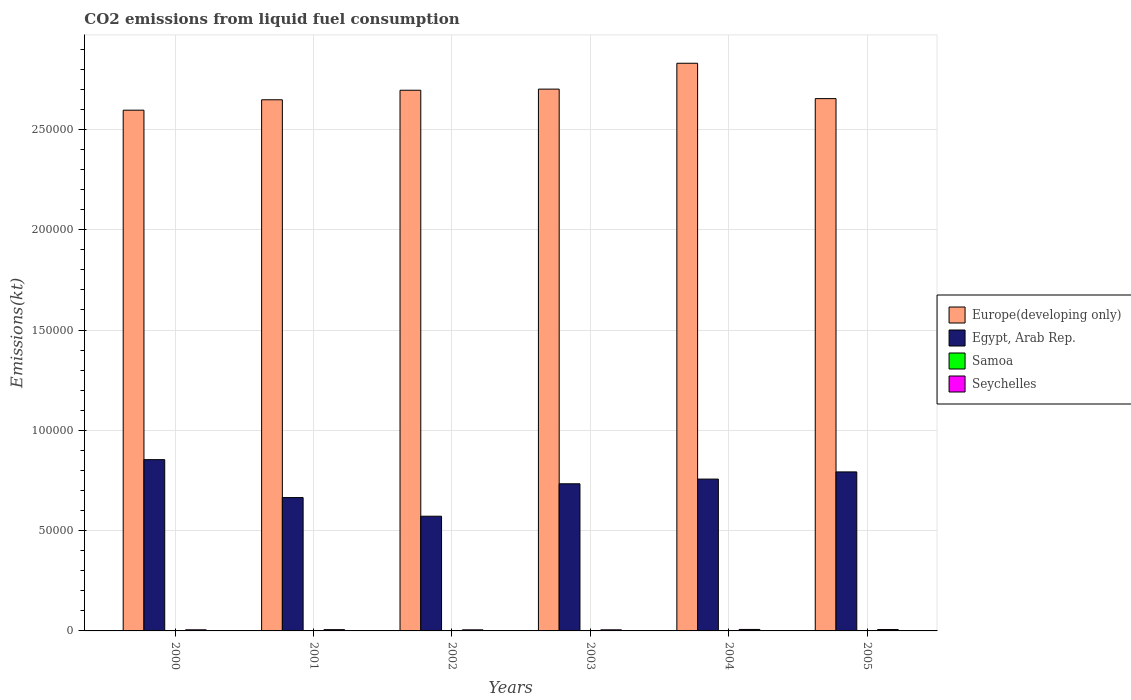What is the amount of CO2 emitted in Samoa in 2000?
Offer a terse response. 139.35. Across all years, what is the maximum amount of CO2 emitted in Europe(developing only)?
Offer a terse response. 2.83e+05. Across all years, what is the minimum amount of CO2 emitted in Egypt, Arab Rep.?
Make the answer very short. 5.72e+04. What is the total amount of CO2 emitted in Samoa in the graph?
Provide a short and direct response. 905.75. What is the difference between the amount of CO2 emitted in Samoa in 2001 and that in 2004?
Give a very brief answer. -18.34. What is the difference between the amount of CO2 emitted in Seychelles in 2000 and the amount of CO2 emitted in Samoa in 2004?
Your answer should be compact. 396.04. What is the average amount of CO2 emitted in Egypt, Arab Rep. per year?
Provide a succinct answer. 7.29e+04. In the year 2004, what is the difference between the amount of CO2 emitted in Egypt, Arab Rep. and amount of CO2 emitted in Samoa?
Make the answer very short. 7.55e+04. What is the ratio of the amount of CO2 emitted in Seychelles in 2003 to that in 2005?
Make the answer very short. 0.8. Is the amount of CO2 emitted in Europe(developing only) in 2001 less than that in 2004?
Make the answer very short. Yes. Is the difference between the amount of CO2 emitted in Egypt, Arab Rep. in 2001 and 2002 greater than the difference between the amount of CO2 emitted in Samoa in 2001 and 2002?
Your answer should be very brief. Yes. What is the difference between the highest and the second highest amount of CO2 emitted in Samoa?
Ensure brevity in your answer.  7.33. What is the difference between the highest and the lowest amount of CO2 emitted in Europe(developing only)?
Give a very brief answer. 2.34e+04. Is the sum of the amount of CO2 emitted in Seychelles in 2000 and 2005 greater than the maximum amount of CO2 emitted in Egypt, Arab Rep. across all years?
Make the answer very short. No. Is it the case that in every year, the sum of the amount of CO2 emitted in Egypt, Arab Rep. and amount of CO2 emitted in Europe(developing only) is greater than the sum of amount of CO2 emitted in Seychelles and amount of CO2 emitted in Samoa?
Your answer should be very brief. Yes. What does the 1st bar from the left in 2003 represents?
Offer a very short reply. Europe(developing only). What does the 1st bar from the right in 2004 represents?
Give a very brief answer. Seychelles. Is it the case that in every year, the sum of the amount of CO2 emitted in Europe(developing only) and amount of CO2 emitted in Egypt, Arab Rep. is greater than the amount of CO2 emitted in Samoa?
Offer a very short reply. Yes. How many bars are there?
Provide a short and direct response. 24. Are all the bars in the graph horizontal?
Ensure brevity in your answer.  No. What is the difference between two consecutive major ticks on the Y-axis?
Make the answer very short. 5.00e+04. Are the values on the major ticks of Y-axis written in scientific E-notation?
Keep it short and to the point. No. How many legend labels are there?
Ensure brevity in your answer.  4. What is the title of the graph?
Offer a terse response. CO2 emissions from liquid fuel consumption. What is the label or title of the X-axis?
Provide a succinct answer. Years. What is the label or title of the Y-axis?
Provide a succinct answer. Emissions(kt). What is the Emissions(kt) of Europe(developing only) in 2000?
Provide a short and direct response. 2.60e+05. What is the Emissions(kt) of Egypt, Arab Rep. in 2000?
Provide a short and direct response. 8.54e+04. What is the Emissions(kt) of Samoa in 2000?
Your answer should be very brief. 139.35. What is the Emissions(kt) in Seychelles in 2000?
Make the answer very short. 557.38. What is the Emissions(kt) of Europe(developing only) in 2001?
Your answer should be compact. 2.65e+05. What is the Emissions(kt) in Egypt, Arab Rep. in 2001?
Your answer should be very brief. 6.65e+04. What is the Emissions(kt) of Samoa in 2001?
Provide a short and direct response. 143.01. What is the Emissions(kt) in Seychelles in 2001?
Your response must be concise. 634.39. What is the Emissions(kt) in Europe(developing only) in 2002?
Make the answer very short. 2.70e+05. What is the Emissions(kt) in Egypt, Arab Rep. in 2002?
Make the answer very short. 5.72e+04. What is the Emissions(kt) in Samoa in 2002?
Ensure brevity in your answer.  143.01. What is the Emissions(kt) of Seychelles in 2002?
Offer a very short reply. 539.05. What is the Emissions(kt) of Europe(developing only) in 2003?
Offer a terse response. 2.70e+05. What is the Emissions(kt) in Egypt, Arab Rep. in 2003?
Keep it short and to the point. 7.34e+04. What is the Emissions(kt) in Samoa in 2003?
Keep it short and to the point. 150.35. What is the Emissions(kt) of Seychelles in 2003?
Your answer should be very brief. 550.05. What is the Emissions(kt) in Europe(developing only) in 2004?
Offer a very short reply. 2.83e+05. What is the Emissions(kt) of Egypt, Arab Rep. in 2004?
Your response must be concise. 7.57e+04. What is the Emissions(kt) of Samoa in 2004?
Offer a terse response. 161.35. What is the Emissions(kt) in Seychelles in 2004?
Your answer should be compact. 737.07. What is the Emissions(kt) of Europe(developing only) in 2005?
Make the answer very short. 2.65e+05. What is the Emissions(kt) in Egypt, Arab Rep. in 2005?
Your answer should be compact. 7.93e+04. What is the Emissions(kt) of Samoa in 2005?
Offer a very short reply. 168.68. What is the Emissions(kt) of Seychelles in 2005?
Give a very brief answer. 689.4. Across all years, what is the maximum Emissions(kt) in Europe(developing only)?
Your answer should be very brief. 2.83e+05. Across all years, what is the maximum Emissions(kt) in Egypt, Arab Rep.?
Give a very brief answer. 8.54e+04. Across all years, what is the maximum Emissions(kt) of Samoa?
Keep it short and to the point. 168.68. Across all years, what is the maximum Emissions(kt) of Seychelles?
Your answer should be compact. 737.07. Across all years, what is the minimum Emissions(kt) of Europe(developing only)?
Keep it short and to the point. 2.60e+05. Across all years, what is the minimum Emissions(kt) of Egypt, Arab Rep.?
Ensure brevity in your answer.  5.72e+04. Across all years, what is the minimum Emissions(kt) in Samoa?
Offer a very short reply. 139.35. Across all years, what is the minimum Emissions(kt) in Seychelles?
Offer a terse response. 539.05. What is the total Emissions(kt) of Europe(developing only) in the graph?
Provide a succinct answer. 1.61e+06. What is the total Emissions(kt) in Egypt, Arab Rep. in the graph?
Your response must be concise. 4.37e+05. What is the total Emissions(kt) of Samoa in the graph?
Provide a succinct answer. 905.75. What is the total Emissions(kt) of Seychelles in the graph?
Keep it short and to the point. 3707.34. What is the difference between the Emissions(kt) of Europe(developing only) in 2000 and that in 2001?
Your response must be concise. -5184.91. What is the difference between the Emissions(kt) of Egypt, Arab Rep. in 2000 and that in 2001?
Your answer should be very brief. 1.89e+04. What is the difference between the Emissions(kt) of Samoa in 2000 and that in 2001?
Keep it short and to the point. -3.67. What is the difference between the Emissions(kt) of Seychelles in 2000 and that in 2001?
Provide a succinct answer. -77.01. What is the difference between the Emissions(kt) in Europe(developing only) in 2000 and that in 2002?
Provide a succinct answer. -9939.01. What is the difference between the Emissions(kt) in Egypt, Arab Rep. in 2000 and that in 2002?
Offer a terse response. 2.82e+04. What is the difference between the Emissions(kt) in Samoa in 2000 and that in 2002?
Provide a short and direct response. -3.67. What is the difference between the Emissions(kt) of Seychelles in 2000 and that in 2002?
Your answer should be very brief. 18.34. What is the difference between the Emissions(kt) of Europe(developing only) in 2000 and that in 2003?
Give a very brief answer. -1.05e+04. What is the difference between the Emissions(kt) in Egypt, Arab Rep. in 2000 and that in 2003?
Offer a very short reply. 1.20e+04. What is the difference between the Emissions(kt) in Samoa in 2000 and that in 2003?
Provide a succinct answer. -11. What is the difference between the Emissions(kt) in Seychelles in 2000 and that in 2003?
Offer a terse response. 7.33. What is the difference between the Emissions(kt) of Europe(developing only) in 2000 and that in 2004?
Make the answer very short. -2.34e+04. What is the difference between the Emissions(kt) in Egypt, Arab Rep. in 2000 and that in 2004?
Make the answer very short. 9691.88. What is the difference between the Emissions(kt) in Samoa in 2000 and that in 2004?
Offer a terse response. -22. What is the difference between the Emissions(kt) in Seychelles in 2000 and that in 2004?
Your response must be concise. -179.68. What is the difference between the Emissions(kt) in Europe(developing only) in 2000 and that in 2005?
Make the answer very short. -5768.21. What is the difference between the Emissions(kt) of Egypt, Arab Rep. in 2000 and that in 2005?
Give a very brief answer. 6112.89. What is the difference between the Emissions(kt) of Samoa in 2000 and that in 2005?
Provide a short and direct response. -29.34. What is the difference between the Emissions(kt) in Seychelles in 2000 and that in 2005?
Make the answer very short. -132.01. What is the difference between the Emissions(kt) of Europe(developing only) in 2001 and that in 2002?
Ensure brevity in your answer.  -4754.1. What is the difference between the Emissions(kt) of Egypt, Arab Rep. in 2001 and that in 2002?
Your response must be concise. 9306.85. What is the difference between the Emissions(kt) in Seychelles in 2001 and that in 2002?
Make the answer very short. 95.34. What is the difference between the Emissions(kt) in Europe(developing only) in 2001 and that in 2003?
Offer a terse response. -5318.34. What is the difference between the Emissions(kt) in Egypt, Arab Rep. in 2001 and that in 2003?
Make the answer very short. -6868.29. What is the difference between the Emissions(kt) in Samoa in 2001 and that in 2003?
Provide a succinct answer. -7.33. What is the difference between the Emissions(kt) of Seychelles in 2001 and that in 2003?
Keep it short and to the point. 84.34. What is the difference between the Emissions(kt) of Europe(developing only) in 2001 and that in 2004?
Offer a terse response. -1.82e+04. What is the difference between the Emissions(kt) of Egypt, Arab Rep. in 2001 and that in 2004?
Your response must be concise. -9211.5. What is the difference between the Emissions(kt) of Samoa in 2001 and that in 2004?
Provide a succinct answer. -18.34. What is the difference between the Emissions(kt) in Seychelles in 2001 and that in 2004?
Provide a succinct answer. -102.68. What is the difference between the Emissions(kt) in Europe(developing only) in 2001 and that in 2005?
Ensure brevity in your answer.  -583.3. What is the difference between the Emissions(kt) of Egypt, Arab Rep. in 2001 and that in 2005?
Offer a very short reply. -1.28e+04. What is the difference between the Emissions(kt) in Samoa in 2001 and that in 2005?
Offer a very short reply. -25.67. What is the difference between the Emissions(kt) in Seychelles in 2001 and that in 2005?
Keep it short and to the point. -55.01. What is the difference between the Emissions(kt) in Europe(developing only) in 2002 and that in 2003?
Keep it short and to the point. -564.24. What is the difference between the Emissions(kt) of Egypt, Arab Rep. in 2002 and that in 2003?
Your answer should be very brief. -1.62e+04. What is the difference between the Emissions(kt) in Samoa in 2002 and that in 2003?
Give a very brief answer. -7.33. What is the difference between the Emissions(kt) in Seychelles in 2002 and that in 2003?
Make the answer very short. -11. What is the difference between the Emissions(kt) in Europe(developing only) in 2002 and that in 2004?
Your response must be concise. -1.35e+04. What is the difference between the Emissions(kt) in Egypt, Arab Rep. in 2002 and that in 2004?
Offer a very short reply. -1.85e+04. What is the difference between the Emissions(kt) in Samoa in 2002 and that in 2004?
Give a very brief answer. -18.34. What is the difference between the Emissions(kt) in Seychelles in 2002 and that in 2004?
Your response must be concise. -198.02. What is the difference between the Emissions(kt) of Europe(developing only) in 2002 and that in 2005?
Provide a short and direct response. 4170.8. What is the difference between the Emissions(kt) in Egypt, Arab Rep. in 2002 and that in 2005?
Your answer should be very brief. -2.21e+04. What is the difference between the Emissions(kt) in Samoa in 2002 and that in 2005?
Ensure brevity in your answer.  -25.67. What is the difference between the Emissions(kt) in Seychelles in 2002 and that in 2005?
Ensure brevity in your answer.  -150.35. What is the difference between the Emissions(kt) in Europe(developing only) in 2003 and that in 2004?
Offer a terse response. -1.29e+04. What is the difference between the Emissions(kt) in Egypt, Arab Rep. in 2003 and that in 2004?
Give a very brief answer. -2343.21. What is the difference between the Emissions(kt) in Samoa in 2003 and that in 2004?
Keep it short and to the point. -11. What is the difference between the Emissions(kt) of Seychelles in 2003 and that in 2004?
Offer a very short reply. -187.02. What is the difference between the Emissions(kt) in Europe(developing only) in 2003 and that in 2005?
Ensure brevity in your answer.  4735.04. What is the difference between the Emissions(kt) of Egypt, Arab Rep. in 2003 and that in 2005?
Keep it short and to the point. -5922.2. What is the difference between the Emissions(kt) in Samoa in 2003 and that in 2005?
Your answer should be compact. -18.34. What is the difference between the Emissions(kt) in Seychelles in 2003 and that in 2005?
Give a very brief answer. -139.35. What is the difference between the Emissions(kt) in Europe(developing only) in 2004 and that in 2005?
Provide a short and direct response. 1.76e+04. What is the difference between the Emissions(kt) of Egypt, Arab Rep. in 2004 and that in 2005?
Your answer should be very brief. -3578.99. What is the difference between the Emissions(kt) in Samoa in 2004 and that in 2005?
Keep it short and to the point. -7.33. What is the difference between the Emissions(kt) in Seychelles in 2004 and that in 2005?
Your response must be concise. 47.67. What is the difference between the Emissions(kt) of Europe(developing only) in 2000 and the Emissions(kt) of Egypt, Arab Rep. in 2001?
Give a very brief answer. 1.93e+05. What is the difference between the Emissions(kt) of Europe(developing only) in 2000 and the Emissions(kt) of Samoa in 2001?
Offer a terse response. 2.59e+05. What is the difference between the Emissions(kt) of Europe(developing only) in 2000 and the Emissions(kt) of Seychelles in 2001?
Ensure brevity in your answer.  2.59e+05. What is the difference between the Emissions(kt) of Egypt, Arab Rep. in 2000 and the Emissions(kt) of Samoa in 2001?
Your answer should be compact. 8.52e+04. What is the difference between the Emissions(kt) in Egypt, Arab Rep. in 2000 and the Emissions(kt) in Seychelles in 2001?
Provide a short and direct response. 8.48e+04. What is the difference between the Emissions(kt) in Samoa in 2000 and the Emissions(kt) in Seychelles in 2001?
Your answer should be compact. -495.05. What is the difference between the Emissions(kt) in Europe(developing only) in 2000 and the Emissions(kt) in Egypt, Arab Rep. in 2002?
Keep it short and to the point. 2.02e+05. What is the difference between the Emissions(kt) of Europe(developing only) in 2000 and the Emissions(kt) of Samoa in 2002?
Your answer should be very brief. 2.59e+05. What is the difference between the Emissions(kt) of Europe(developing only) in 2000 and the Emissions(kt) of Seychelles in 2002?
Offer a terse response. 2.59e+05. What is the difference between the Emissions(kt) of Egypt, Arab Rep. in 2000 and the Emissions(kt) of Samoa in 2002?
Your response must be concise. 8.52e+04. What is the difference between the Emissions(kt) in Egypt, Arab Rep. in 2000 and the Emissions(kt) in Seychelles in 2002?
Ensure brevity in your answer.  8.49e+04. What is the difference between the Emissions(kt) in Samoa in 2000 and the Emissions(kt) in Seychelles in 2002?
Ensure brevity in your answer.  -399.7. What is the difference between the Emissions(kt) of Europe(developing only) in 2000 and the Emissions(kt) of Egypt, Arab Rep. in 2003?
Provide a short and direct response. 1.86e+05. What is the difference between the Emissions(kt) of Europe(developing only) in 2000 and the Emissions(kt) of Samoa in 2003?
Give a very brief answer. 2.59e+05. What is the difference between the Emissions(kt) of Europe(developing only) in 2000 and the Emissions(kt) of Seychelles in 2003?
Offer a very short reply. 2.59e+05. What is the difference between the Emissions(kt) of Egypt, Arab Rep. in 2000 and the Emissions(kt) of Samoa in 2003?
Your answer should be compact. 8.52e+04. What is the difference between the Emissions(kt) of Egypt, Arab Rep. in 2000 and the Emissions(kt) of Seychelles in 2003?
Your response must be concise. 8.48e+04. What is the difference between the Emissions(kt) in Samoa in 2000 and the Emissions(kt) in Seychelles in 2003?
Provide a succinct answer. -410.7. What is the difference between the Emissions(kt) of Europe(developing only) in 2000 and the Emissions(kt) of Egypt, Arab Rep. in 2004?
Your answer should be very brief. 1.84e+05. What is the difference between the Emissions(kt) in Europe(developing only) in 2000 and the Emissions(kt) in Samoa in 2004?
Keep it short and to the point. 2.59e+05. What is the difference between the Emissions(kt) of Europe(developing only) in 2000 and the Emissions(kt) of Seychelles in 2004?
Make the answer very short. 2.59e+05. What is the difference between the Emissions(kt) of Egypt, Arab Rep. in 2000 and the Emissions(kt) of Samoa in 2004?
Ensure brevity in your answer.  8.52e+04. What is the difference between the Emissions(kt) in Egypt, Arab Rep. in 2000 and the Emissions(kt) in Seychelles in 2004?
Your answer should be compact. 8.47e+04. What is the difference between the Emissions(kt) in Samoa in 2000 and the Emissions(kt) in Seychelles in 2004?
Provide a short and direct response. -597.72. What is the difference between the Emissions(kt) in Europe(developing only) in 2000 and the Emissions(kt) in Egypt, Arab Rep. in 2005?
Offer a very short reply. 1.80e+05. What is the difference between the Emissions(kt) of Europe(developing only) in 2000 and the Emissions(kt) of Samoa in 2005?
Make the answer very short. 2.59e+05. What is the difference between the Emissions(kt) of Europe(developing only) in 2000 and the Emissions(kt) of Seychelles in 2005?
Provide a succinct answer. 2.59e+05. What is the difference between the Emissions(kt) of Egypt, Arab Rep. in 2000 and the Emissions(kt) of Samoa in 2005?
Your response must be concise. 8.52e+04. What is the difference between the Emissions(kt) in Egypt, Arab Rep. in 2000 and the Emissions(kt) in Seychelles in 2005?
Your response must be concise. 8.47e+04. What is the difference between the Emissions(kt) of Samoa in 2000 and the Emissions(kt) of Seychelles in 2005?
Offer a very short reply. -550.05. What is the difference between the Emissions(kt) in Europe(developing only) in 2001 and the Emissions(kt) in Egypt, Arab Rep. in 2002?
Make the answer very short. 2.08e+05. What is the difference between the Emissions(kt) of Europe(developing only) in 2001 and the Emissions(kt) of Samoa in 2002?
Give a very brief answer. 2.65e+05. What is the difference between the Emissions(kt) in Europe(developing only) in 2001 and the Emissions(kt) in Seychelles in 2002?
Ensure brevity in your answer.  2.64e+05. What is the difference between the Emissions(kt) of Egypt, Arab Rep. in 2001 and the Emissions(kt) of Samoa in 2002?
Give a very brief answer. 6.63e+04. What is the difference between the Emissions(kt) of Egypt, Arab Rep. in 2001 and the Emissions(kt) of Seychelles in 2002?
Make the answer very short. 6.59e+04. What is the difference between the Emissions(kt) of Samoa in 2001 and the Emissions(kt) of Seychelles in 2002?
Your answer should be very brief. -396.04. What is the difference between the Emissions(kt) of Europe(developing only) in 2001 and the Emissions(kt) of Egypt, Arab Rep. in 2003?
Provide a succinct answer. 1.91e+05. What is the difference between the Emissions(kt) of Europe(developing only) in 2001 and the Emissions(kt) of Samoa in 2003?
Provide a short and direct response. 2.65e+05. What is the difference between the Emissions(kt) of Europe(developing only) in 2001 and the Emissions(kt) of Seychelles in 2003?
Give a very brief answer. 2.64e+05. What is the difference between the Emissions(kt) of Egypt, Arab Rep. in 2001 and the Emissions(kt) of Samoa in 2003?
Keep it short and to the point. 6.63e+04. What is the difference between the Emissions(kt) of Egypt, Arab Rep. in 2001 and the Emissions(kt) of Seychelles in 2003?
Your answer should be very brief. 6.59e+04. What is the difference between the Emissions(kt) of Samoa in 2001 and the Emissions(kt) of Seychelles in 2003?
Ensure brevity in your answer.  -407.04. What is the difference between the Emissions(kt) in Europe(developing only) in 2001 and the Emissions(kt) in Egypt, Arab Rep. in 2004?
Provide a succinct answer. 1.89e+05. What is the difference between the Emissions(kt) in Europe(developing only) in 2001 and the Emissions(kt) in Samoa in 2004?
Make the answer very short. 2.65e+05. What is the difference between the Emissions(kt) in Europe(developing only) in 2001 and the Emissions(kt) in Seychelles in 2004?
Make the answer very short. 2.64e+05. What is the difference between the Emissions(kt) in Egypt, Arab Rep. in 2001 and the Emissions(kt) in Samoa in 2004?
Provide a succinct answer. 6.63e+04. What is the difference between the Emissions(kt) in Egypt, Arab Rep. in 2001 and the Emissions(kt) in Seychelles in 2004?
Your answer should be very brief. 6.57e+04. What is the difference between the Emissions(kt) in Samoa in 2001 and the Emissions(kt) in Seychelles in 2004?
Provide a short and direct response. -594.05. What is the difference between the Emissions(kt) of Europe(developing only) in 2001 and the Emissions(kt) of Egypt, Arab Rep. in 2005?
Offer a very short reply. 1.86e+05. What is the difference between the Emissions(kt) of Europe(developing only) in 2001 and the Emissions(kt) of Samoa in 2005?
Offer a very short reply. 2.65e+05. What is the difference between the Emissions(kt) in Europe(developing only) in 2001 and the Emissions(kt) in Seychelles in 2005?
Keep it short and to the point. 2.64e+05. What is the difference between the Emissions(kt) of Egypt, Arab Rep. in 2001 and the Emissions(kt) of Samoa in 2005?
Keep it short and to the point. 6.63e+04. What is the difference between the Emissions(kt) of Egypt, Arab Rep. in 2001 and the Emissions(kt) of Seychelles in 2005?
Your response must be concise. 6.58e+04. What is the difference between the Emissions(kt) in Samoa in 2001 and the Emissions(kt) in Seychelles in 2005?
Provide a succinct answer. -546.38. What is the difference between the Emissions(kt) of Europe(developing only) in 2002 and the Emissions(kt) of Egypt, Arab Rep. in 2003?
Your response must be concise. 1.96e+05. What is the difference between the Emissions(kt) in Europe(developing only) in 2002 and the Emissions(kt) in Samoa in 2003?
Provide a short and direct response. 2.69e+05. What is the difference between the Emissions(kt) in Europe(developing only) in 2002 and the Emissions(kt) in Seychelles in 2003?
Provide a succinct answer. 2.69e+05. What is the difference between the Emissions(kt) in Egypt, Arab Rep. in 2002 and the Emissions(kt) in Samoa in 2003?
Provide a short and direct response. 5.70e+04. What is the difference between the Emissions(kt) in Egypt, Arab Rep. in 2002 and the Emissions(kt) in Seychelles in 2003?
Provide a succinct answer. 5.66e+04. What is the difference between the Emissions(kt) of Samoa in 2002 and the Emissions(kt) of Seychelles in 2003?
Ensure brevity in your answer.  -407.04. What is the difference between the Emissions(kt) in Europe(developing only) in 2002 and the Emissions(kt) in Egypt, Arab Rep. in 2004?
Provide a succinct answer. 1.94e+05. What is the difference between the Emissions(kt) in Europe(developing only) in 2002 and the Emissions(kt) in Samoa in 2004?
Make the answer very short. 2.69e+05. What is the difference between the Emissions(kt) of Europe(developing only) in 2002 and the Emissions(kt) of Seychelles in 2004?
Make the answer very short. 2.69e+05. What is the difference between the Emissions(kt) in Egypt, Arab Rep. in 2002 and the Emissions(kt) in Samoa in 2004?
Offer a terse response. 5.70e+04. What is the difference between the Emissions(kt) in Egypt, Arab Rep. in 2002 and the Emissions(kt) in Seychelles in 2004?
Offer a terse response. 5.64e+04. What is the difference between the Emissions(kt) of Samoa in 2002 and the Emissions(kt) of Seychelles in 2004?
Offer a terse response. -594.05. What is the difference between the Emissions(kt) in Europe(developing only) in 2002 and the Emissions(kt) in Egypt, Arab Rep. in 2005?
Give a very brief answer. 1.90e+05. What is the difference between the Emissions(kt) in Europe(developing only) in 2002 and the Emissions(kt) in Samoa in 2005?
Give a very brief answer. 2.69e+05. What is the difference between the Emissions(kt) of Europe(developing only) in 2002 and the Emissions(kt) of Seychelles in 2005?
Your answer should be very brief. 2.69e+05. What is the difference between the Emissions(kt) of Egypt, Arab Rep. in 2002 and the Emissions(kt) of Samoa in 2005?
Offer a very short reply. 5.70e+04. What is the difference between the Emissions(kt) in Egypt, Arab Rep. in 2002 and the Emissions(kt) in Seychelles in 2005?
Make the answer very short. 5.65e+04. What is the difference between the Emissions(kt) in Samoa in 2002 and the Emissions(kt) in Seychelles in 2005?
Offer a terse response. -546.38. What is the difference between the Emissions(kt) of Europe(developing only) in 2003 and the Emissions(kt) of Egypt, Arab Rep. in 2004?
Provide a short and direct response. 1.94e+05. What is the difference between the Emissions(kt) of Europe(developing only) in 2003 and the Emissions(kt) of Samoa in 2004?
Your response must be concise. 2.70e+05. What is the difference between the Emissions(kt) in Europe(developing only) in 2003 and the Emissions(kt) in Seychelles in 2004?
Ensure brevity in your answer.  2.69e+05. What is the difference between the Emissions(kt) of Egypt, Arab Rep. in 2003 and the Emissions(kt) of Samoa in 2004?
Offer a terse response. 7.32e+04. What is the difference between the Emissions(kt) of Egypt, Arab Rep. in 2003 and the Emissions(kt) of Seychelles in 2004?
Ensure brevity in your answer.  7.26e+04. What is the difference between the Emissions(kt) in Samoa in 2003 and the Emissions(kt) in Seychelles in 2004?
Make the answer very short. -586.72. What is the difference between the Emissions(kt) in Europe(developing only) in 2003 and the Emissions(kt) in Egypt, Arab Rep. in 2005?
Offer a very short reply. 1.91e+05. What is the difference between the Emissions(kt) in Europe(developing only) in 2003 and the Emissions(kt) in Samoa in 2005?
Offer a terse response. 2.70e+05. What is the difference between the Emissions(kt) in Europe(developing only) in 2003 and the Emissions(kt) in Seychelles in 2005?
Provide a short and direct response. 2.69e+05. What is the difference between the Emissions(kt) in Egypt, Arab Rep. in 2003 and the Emissions(kt) in Samoa in 2005?
Offer a terse response. 7.32e+04. What is the difference between the Emissions(kt) of Egypt, Arab Rep. in 2003 and the Emissions(kt) of Seychelles in 2005?
Make the answer very short. 7.27e+04. What is the difference between the Emissions(kt) of Samoa in 2003 and the Emissions(kt) of Seychelles in 2005?
Provide a short and direct response. -539.05. What is the difference between the Emissions(kt) of Europe(developing only) in 2004 and the Emissions(kt) of Egypt, Arab Rep. in 2005?
Make the answer very short. 2.04e+05. What is the difference between the Emissions(kt) of Europe(developing only) in 2004 and the Emissions(kt) of Samoa in 2005?
Provide a succinct answer. 2.83e+05. What is the difference between the Emissions(kt) in Europe(developing only) in 2004 and the Emissions(kt) in Seychelles in 2005?
Ensure brevity in your answer.  2.82e+05. What is the difference between the Emissions(kt) of Egypt, Arab Rep. in 2004 and the Emissions(kt) of Samoa in 2005?
Offer a terse response. 7.55e+04. What is the difference between the Emissions(kt) in Egypt, Arab Rep. in 2004 and the Emissions(kt) in Seychelles in 2005?
Offer a very short reply. 7.50e+04. What is the difference between the Emissions(kt) in Samoa in 2004 and the Emissions(kt) in Seychelles in 2005?
Ensure brevity in your answer.  -528.05. What is the average Emissions(kt) in Europe(developing only) per year?
Provide a succinct answer. 2.69e+05. What is the average Emissions(kt) in Egypt, Arab Rep. per year?
Provide a succinct answer. 7.29e+04. What is the average Emissions(kt) of Samoa per year?
Keep it short and to the point. 150.96. What is the average Emissions(kt) of Seychelles per year?
Your response must be concise. 617.89. In the year 2000, what is the difference between the Emissions(kt) of Europe(developing only) and Emissions(kt) of Egypt, Arab Rep.?
Provide a succinct answer. 1.74e+05. In the year 2000, what is the difference between the Emissions(kt) of Europe(developing only) and Emissions(kt) of Samoa?
Give a very brief answer. 2.59e+05. In the year 2000, what is the difference between the Emissions(kt) in Europe(developing only) and Emissions(kt) in Seychelles?
Offer a terse response. 2.59e+05. In the year 2000, what is the difference between the Emissions(kt) in Egypt, Arab Rep. and Emissions(kt) in Samoa?
Your answer should be compact. 8.53e+04. In the year 2000, what is the difference between the Emissions(kt) in Egypt, Arab Rep. and Emissions(kt) in Seychelles?
Your answer should be compact. 8.48e+04. In the year 2000, what is the difference between the Emissions(kt) of Samoa and Emissions(kt) of Seychelles?
Provide a succinct answer. -418.04. In the year 2001, what is the difference between the Emissions(kt) of Europe(developing only) and Emissions(kt) of Egypt, Arab Rep.?
Your answer should be compact. 1.98e+05. In the year 2001, what is the difference between the Emissions(kt) in Europe(developing only) and Emissions(kt) in Samoa?
Offer a very short reply. 2.65e+05. In the year 2001, what is the difference between the Emissions(kt) in Europe(developing only) and Emissions(kt) in Seychelles?
Your answer should be very brief. 2.64e+05. In the year 2001, what is the difference between the Emissions(kt) of Egypt, Arab Rep. and Emissions(kt) of Samoa?
Your answer should be very brief. 6.63e+04. In the year 2001, what is the difference between the Emissions(kt) of Egypt, Arab Rep. and Emissions(kt) of Seychelles?
Provide a succinct answer. 6.59e+04. In the year 2001, what is the difference between the Emissions(kt) in Samoa and Emissions(kt) in Seychelles?
Your answer should be very brief. -491.38. In the year 2002, what is the difference between the Emissions(kt) in Europe(developing only) and Emissions(kt) in Egypt, Arab Rep.?
Provide a short and direct response. 2.12e+05. In the year 2002, what is the difference between the Emissions(kt) in Europe(developing only) and Emissions(kt) in Samoa?
Offer a very short reply. 2.69e+05. In the year 2002, what is the difference between the Emissions(kt) of Europe(developing only) and Emissions(kt) of Seychelles?
Your response must be concise. 2.69e+05. In the year 2002, what is the difference between the Emissions(kt) in Egypt, Arab Rep. and Emissions(kt) in Samoa?
Offer a very short reply. 5.70e+04. In the year 2002, what is the difference between the Emissions(kt) of Egypt, Arab Rep. and Emissions(kt) of Seychelles?
Give a very brief answer. 5.66e+04. In the year 2002, what is the difference between the Emissions(kt) in Samoa and Emissions(kt) in Seychelles?
Keep it short and to the point. -396.04. In the year 2003, what is the difference between the Emissions(kt) of Europe(developing only) and Emissions(kt) of Egypt, Arab Rep.?
Your response must be concise. 1.97e+05. In the year 2003, what is the difference between the Emissions(kt) of Europe(developing only) and Emissions(kt) of Samoa?
Your answer should be compact. 2.70e+05. In the year 2003, what is the difference between the Emissions(kt) of Europe(developing only) and Emissions(kt) of Seychelles?
Keep it short and to the point. 2.70e+05. In the year 2003, what is the difference between the Emissions(kt) in Egypt, Arab Rep. and Emissions(kt) in Samoa?
Provide a succinct answer. 7.32e+04. In the year 2003, what is the difference between the Emissions(kt) in Egypt, Arab Rep. and Emissions(kt) in Seychelles?
Offer a terse response. 7.28e+04. In the year 2003, what is the difference between the Emissions(kt) of Samoa and Emissions(kt) of Seychelles?
Provide a succinct answer. -399.7. In the year 2004, what is the difference between the Emissions(kt) in Europe(developing only) and Emissions(kt) in Egypt, Arab Rep.?
Your answer should be very brief. 2.07e+05. In the year 2004, what is the difference between the Emissions(kt) in Europe(developing only) and Emissions(kt) in Samoa?
Provide a short and direct response. 2.83e+05. In the year 2004, what is the difference between the Emissions(kt) in Europe(developing only) and Emissions(kt) in Seychelles?
Make the answer very short. 2.82e+05. In the year 2004, what is the difference between the Emissions(kt) in Egypt, Arab Rep. and Emissions(kt) in Samoa?
Your answer should be compact. 7.55e+04. In the year 2004, what is the difference between the Emissions(kt) in Egypt, Arab Rep. and Emissions(kt) in Seychelles?
Your response must be concise. 7.50e+04. In the year 2004, what is the difference between the Emissions(kt) of Samoa and Emissions(kt) of Seychelles?
Offer a very short reply. -575.72. In the year 2005, what is the difference between the Emissions(kt) in Europe(developing only) and Emissions(kt) in Egypt, Arab Rep.?
Offer a terse response. 1.86e+05. In the year 2005, what is the difference between the Emissions(kt) of Europe(developing only) and Emissions(kt) of Samoa?
Offer a terse response. 2.65e+05. In the year 2005, what is the difference between the Emissions(kt) of Europe(developing only) and Emissions(kt) of Seychelles?
Your response must be concise. 2.65e+05. In the year 2005, what is the difference between the Emissions(kt) in Egypt, Arab Rep. and Emissions(kt) in Samoa?
Your answer should be compact. 7.91e+04. In the year 2005, what is the difference between the Emissions(kt) of Egypt, Arab Rep. and Emissions(kt) of Seychelles?
Provide a succinct answer. 7.86e+04. In the year 2005, what is the difference between the Emissions(kt) of Samoa and Emissions(kt) of Seychelles?
Provide a short and direct response. -520.71. What is the ratio of the Emissions(kt) in Europe(developing only) in 2000 to that in 2001?
Give a very brief answer. 0.98. What is the ratio of the Emissions(kt) of Egypt, Arab Rep. in 2000 to that in 2001?
Your answer should be very brief. 1.28. What is the ratio of the Emissions(kt) in Samoa in 2000 to that in 2001?
Keep it short and to the point. 0.97. What is the ratio of the Emissions(kt) in Seychelles in 2000 to that in 2001?
Your response must be concise. 0.88. What is the ratio of the Emissions(kt) of Europe(developing only) in 2000 to that in 2002?
Offer a terse response. 0.96. What is the ratio of the Emissions(kt) of Egypt, Arab Rep. in 2000 to that in 2002?
Ensure brevity in your answer.  1.49. What is the ratio of the Emissions(kt) in Samoa in 2000 to that in 2002?
Give a very brief answer. 0.97. What is the ratio of the Emissions(kt) in Seychelles in 2000 to that in 2002?
Give a very brief answer. 1.03. What is the ratio of the Emissions(kt) in Europe(developing only) in 2000 to that in 2003?
Ensure brevity in your answer.  0.96. What is the ratio of the Emissions(kt) in Egypt, Arab Rep. in 2000 to that in 2003?
Provide a short and direct response. 1.16. What is the ratio of the Emissions(kt) in Samoa in 2000 to that in 2003?
Give a very brief answer. 0.93. What is the ratio of the Emissions(kt) of Seychelles in 2000 to that in 2003?
Your response must be concise. 1.01. What is the ratio of the Emissions(kt) in Europe(developing only) in 2000 to that in 2004?
Your answer should be very brief. 0.92. What is the ratio of the Emissions(kt) in Egypt, Arab Rep. in 2000 to that in 2004?
Keep it short and to the point. 1.13. What is the ratio of the Emissions(kt) of Samoa in 2000 to that in 2004?
Keep it short and to the point. 0.86. What is the ratio of the Emissions(kt) in Seychelles in 2000 to that in 2004?
Ensure brevity in your answer.  0.76. What is the ratio of the Emissions(kt) in Europe(developing only) in 2000 to that in 2005?
Your answer should be very brief. 0.98. What is the ratio of the Emissions(kt) in Egypt, Arab Rep. in 2000 to that in 2005?
Your answer should be very brief. 1.08. What is the ratio of the Emissions(kt) of Samoa in 2000 to that in 2005?
Provide a short and direct response. 0.83. What is the ratio of the Emissions(kt) of Seychelles in 2000 to that in 2005?
Provide a succinct answer. 0.81. What is the ratio of the Emissions(kt) of Europe(developing only) in 2001 to that in 2002?
Provide a succinct answer. 0.98. What is the ratio of the Emissions(kt) in Egypt, Arab Rep. in 2001 to that in 2002?
Give a very brief answer. 1.16. What is the ratio of the Emissions(kt) in Seychelles in 2001 to that in 2002?
Provide a short and direct response. 1.18. What is the ratio of the Emissions(kt) of Europe(developing only) in 2001 to that in 2003?
Ensure brevity in your answer.  0.98. What is the ratio of the Emissions(kt) of Egypt, Arab Rep. in 2001 to that in 2003?
Provide a short and direct response. 0.91. What is the ratio of the Emissions(kt) of Samoa in 2001 to that in 2003?
Your response must be concise. 0.95. What is the ratio of the Emissions(kt) in Seychelles in 2001 to that in 2003?
Your response must be concise. 1.15. What is the ratio of the Emissions(kt) in Europe(developing only) in 2001 to that in 2004?
Your response must be concise. 0.94. What is the ratio of the Emissions(kt) in Egypt, Arab Rep. in 2001 to that in 2004?
Ensure brevity in your answer.  0.88. What is the ratio of the Emissions(kt) of Samoa in 2001 to that in 2004?
Provide a short and direct response. 0.89. What is the ratio of the Emissions(kt) of Seychelles in 2001 to that in 2004?
Your answer should be very brief. 0.86. What is the ratio of the Emissions(kt) in Europe(developing only) in 2001 to that in 2005?
Your answer should be compact. 1. What is the ratio of the Emissions(kt) of Egypt, Arab Rep. in 2001 to that in 2005?
Your response must be concise. 0.84. What is the ratio of the Emissions(kt) in Samoa in 2001 to that in 2005?
Your answer should be very brief. 0.85. What is the ratio of the Emissions(kt) of Seychelles in 2001 to that in 2005?
Provide a succinct answer. 0.92. What is the ratio of the Emissions(kt) in Egypt, Arab Rep. in 2002 to that in 2003?
Offer a very short reply. 0.78. What is the ratio of the Emissions(kt) of Samoa in 2002 to that in 2003?
Offer a very short reply. 0.95. What is the ratio of the Emissions(kt) in Europe(developing only) in 2002 to that in 2004?
Give a very brief answer. 0.95. What is the ratio of the Emissions(kt) of Egypt, Arab Rep. in 2002 to that in 2004?
Give a very brief answer. 0.76. What is the ratio of the Emissions(kt) of Samoa in 2002 to that in 2004?
Your answer should be very brief. 0.89. What is the ratio of the Emissions(kt) of Seychelles in 2002 to that in 2004?
Give a very brief answer. 0.73. What is the ratio of the Emissions(kt) of Europe(developing only) in 2002 to that in 2005?
Provide a short and direct response. 1.02. What is the ratio of the Emissions(kt) of Egypt, Arab Rep. in 2002 to that in 2005?
Provide a succinct answer. 0.72. What is the ratio of the Emissions(kt) in Samoa in 2002 to that in 2005?
Your response must be concise. 0.85. What is the ratio of the Emissions(kt) of Seychelles in 2002 to that in 2005?
Offer a very short reply. 0.78. What is the ratio of the Emissions(kt) in Europe(developing only) in 2003 to that in 2004?
Make the answer very short. 0.95. What is the ratio of the Emissions(kt) in Egypt, Arab Rep. in 2003 to that in 2004?
Offer a very short reply. 0.97. What is the ratio of the Emissions(kt) of Samoa in 2003 to that in 2004?
Provide a succinct answer. 0.93. What is the ratio of the Emissions(kt) in Seychelles in 2003 to that in 2004?
Keep it short and to the point. 0.75. What is the ratio of the Emissions(kt) of Europe(developing only) in 2003 to that in 2005?
Offer a very short reply. 1.02. What is the ratio of the Emissions(kt) in Egypt, Arab Rep. in 2003 to that in 2005?
Ensure brevity in your answer.  0.93. What is the ratio of the Emissions(kt) of Samoa in 2003 to that in 2005?
Provide a succinct answer. 0.89. What is the ratio of the Emissions(kt) of Seychelles in 2003 to that in 2005?
Offer a terse response. 0.8. What is the ratio of the Emissions(kt) of Europe(developing only) in 2004 to that in 2005?
Keep it short and to the point. 1.07. What is the ratio of the Emissions(kt) of Egypt, Arab Rep. in 2004 to that in 2005?
Give a very brief answer. 0.95. What is the ratio of the Emissions(kt) in Samoa in 2004 to that in 2005?
Your answer should be compact. 0.96. What is the ratio of the Emissions(kt) in Seychelles in 2004 to that in 2005?
Ensure brevity in your answer.  1.07. What is the difference between the highest and the second highest Emissions(kt) in Europe(developing only)?
Your answer should be very brief. 1.29e+04. What is the difference between the highest and the second highest Emissions(kt) in Egypt, Arab Rep.?
Make the answer very short. 6112.89. What is the difference between the highest and the second highest Emissions(kt) of Samoa?
Provide a short and direct response. 7.33. What is the difference between the highest and the second highest Emissions(kt) in Seychelles?
Offer a terse response. 47.67. What is the difference between the highest and the lowest Emissions(kt) of Europe(developing only)?
Provide a short and direct response. 2.34e+04. What is the difference between the highest and the lowest Emissions(kt) of Egypt, Arab Rep.?
Offer a terse response. 2.82e+04. What is the difference between the highest and the lowest Emissions(kt) of Samoa?
Your response must be concise. 29.34. What is the difference between the highest and the lowest Emissions(kt) in Seychelles?
Provide a succinct answer. 198.02. 